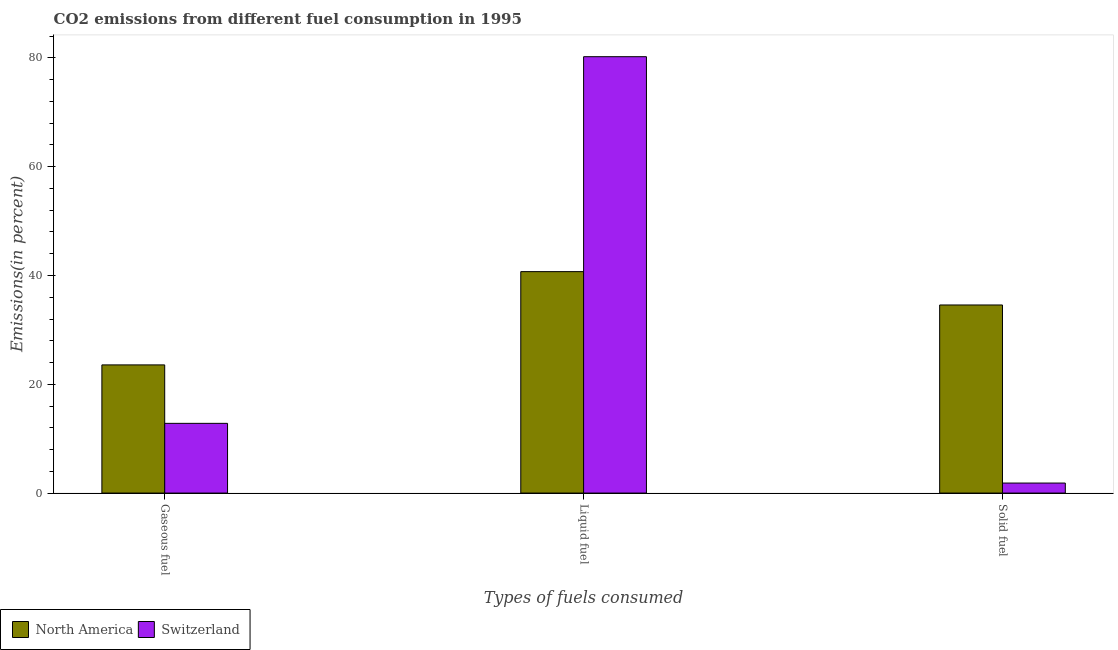How many different coloured bars are there?
Provide a short and direct response. 2. What is the label of the 1st group of bars from the left?
Your answer should be very brief. Gaseous fuel. What is the percentage of gaseous fuel emission in Switzerland?
Your response must be concise. 12.82. Across all countries, what is the maximum percentage of solid fuel emission?
Keep it short and to the point. 34.58. Across all countries, what is the minimum percentage of liquid fuel emission?
Provide a succinct answer. 40.71. In which country was the percentage of solid fuel emission maximum?
Offer a very short reply. North America. In which country was the percentage of gaseous fuel emission minimum?
Offer a terse response. Switzerland. What is the total percentage of solid fuel emission in the graph?
Make the answer very short. 36.42. What is the difference between the percentage of solid fuel emission in North America and that in Switzerland?
Make the answer very short. 32.74. What is the difference between the percentage of gaseous fuel emission in North America and the percentage of liquid fuel emission in Switzerland?
Provide a succinct answer. -56.66. What is the average percentage of solid fuel emission per country?
Your answer should be compact. 18.21. What is the difference between the percentage of gaseous fuel emission and percentage of liquid fuel emission in Switzerland?
Give a very brief answer. -67.41. In how many countries, is the percentage of solid fuel emission greater than 36 %?
Offer a terse response. 0. What is the ratio of the percentage of gaseous fuel emission in Switzerland to that in North America?
Make the answer very short. 0.54. Is the difference between the percentage of gaseous fuel emission in North America and Switzerland greater than the difference between the percentage of solid fuel emission in North America and Switzerland?
Keep it short and to the point. No. What is the difference between the highest and the second highest percentage of gaseous fuel emission?
Give a very brief answer. 10.75. What is the difference between the highest and the lowest percentage of solid fuel emission?
Keep it short and to the point. 32.74. Is the sum of the percentage of solid fuel emission in North America and Switzerland greater than the maximum percentage of liquid fuel emission across all countries?
Give a very brief answer. No. What does the 1st bar from the left in Liquid fuel represents?
Keep it short and to the point. North America. What does the 1st bar from the right in Liquid fuel represents?
Keep it short and to the point. Switzerland. Does the graph contain any zero values?
Offer a very short reply. No. Where does the legend appear in the graph?
Keep it short and to the point. Bottom left. How are the legend labels stacked?
Ensure brevity in your answer.  Horizontal. What is the title of the graph?
Ensure brevity in your answer.  CO2 emissions from different fuel consumption in 1995. What is the label or title of the X-axis?
Your response must be concise. Types of fuels consumed. What is the label or title of the Y-axis?
Your answer should be compact. Emissions(in percent). What is the Emissions(in percent) of North America in Gaseous fuel?
Your response must be concise. 23.56. What is the Emissions(in percent) of Switzerland in Gaseous fuel?
Ensure brevity in your answer.  12.82. What is the Emissions(in percent) in North America in Liquid fuel?
Provide a succinct answer. 40.71. What is the Emissions(in percent) in Switzerland in Liquid fuel?
Ensure brevity in your answer.  80.23. What is the Emissions(in percent) of North America in Solid fuel?
Provide a succinct answer. 34.58. What is the Emissions(in percent) of Switzerland in Solid fuel?
Provide a short and direct response. 1.84. Across all Types of fuels consumed, what is the maximum Emissions(in percent) in North America?
Provide a short and direct response. 40.71. Across all Types of fuels consumed, what is the maximum Emissions(in percent) in Switzerland?
Offer a very short reply. 80.23. Across all Types of fuels consumed, what is the minimum Emissions(in percent) of North America?
Offer a terse response. 23.56. Across all Types of fuels consumed, what is the minimum Emissions(in percent) of Switzerland?
Offer a terse response. 1.84. What is the total Emissions(in percent) of North America in the graph?
Your answer should be compact. 98.86. What is the total Emissions(in percent) of Switzerland in the graph?
Your answer should be compact. 94.89. What is the difference between the Emissions(in percent) in North America in Gaseous fuel and that in Liquid fuel?
Provide a short and direct response. -17.15. What is the difference between the Emissions(in percent) of Switzerland in Gaseous fuel and that in Liquid fuel?
Your answer should be very brief. -67.41. What is the difference between the Emissions(in percent) of North America in Gaseous fuel and that in Solid fuel?
Your answer should be compact. -11.02. What is the difference between the Emissions(in percent) in Switzerland in Gaseous fuel and that in Solid fuel?
Offer a very short reply. 10.97. What is the difference between the Emissions(in percent) in North America in Liquid fuel and that in Solid fuel?
Your response must be concise. 6.13. What is the difference between the Emissions(in percent) in Switzerland in Liquid fuel and that in Solid fuel?
Your answer should be very brief. 78.39. What is the difference between the Emissions(in percent) in North America in Gaseous fuel and the Emissions(in percent) in Switzerland in Liquid fuel?
Your response must be concise. -56.66. What is the difference between the Emissions(in percent) of North America in Gaseous fuel and the Emissions(in percent) of Switzerland in Solid fuel?
Keep it short and to the point. 21.72. What is the difference between the Emissions(in percent) in North America in Liquid fuel and the Emissions(in percent) in Switzerland in Solid fuel?
Make the answer very short. 38.87. What is the average Emissions(in percent) in North America per Types of fuels consumed?
Your answer should be compact. 32.95. What is the average Emissions(in percent) in Switzerland per Types of fuels consumed?
Give a very brief answer. 31.63. What is the difference between the Emissions(in percent) in North America and Emissions(in percent) in Switzerland in Gaseous fuel?
Your response must be concise. 10.75. What is the difference between the Emissions(in percent) in North America and Emissions(in percent) in Switzerland in Liquid fuel?
Your answer should be compact. -39.52. What is the difference between the Emissions(in percent) of North America and Emissions(in percent) of Switzerland in Solid fuel?
Provide a succinct answer. 32.74. What is the ratio of the Emissions(in percent) in North America in Gaseous fuel to that in Liquid fuel?
Your response must be concise. 0.58. What is the ratio of the Emissions(in percent) in Switzerland in Gaseous fuel to that in Liquid fuel?
Provide a short and direct response. 0.16. What is the ratio of the Emissions(in percent) of North America in Gaseous fuel to that in Solid fuel?
Offer a very short reply. 0.68. What is the ratio of the Emissions(in percent) in Switzerland in Gaseous fuel to that in Solid fuel?
Your answer should be very brief. 6.96. What is the ratio of the Emissions(in percent) of North America in Liquid fuel to that in Solid fuel?
Your response must be concise. 1.18. What is the ratio of the Emissions(in percent) in Switzerland in Liquid fuel to that in Solid fuel?
Ensure brevity in your answer.  43.56. What is the difference between the highest and the second highest Emissions(in percent) in North America?
Offer a terse response. 6.13. What is the difference between the highest and the second highest Emissions(in percent) of Switzerland?
Give a very brief answer. 67.41. What is the difference between the highest and the lowest Emissions(in percent) of North America?
Give a very brief answer. 17.15. What is the difference between the highest and the lowest Emissions(in percent) of Switzerland?
Provide a succinct answer. 78.39. 